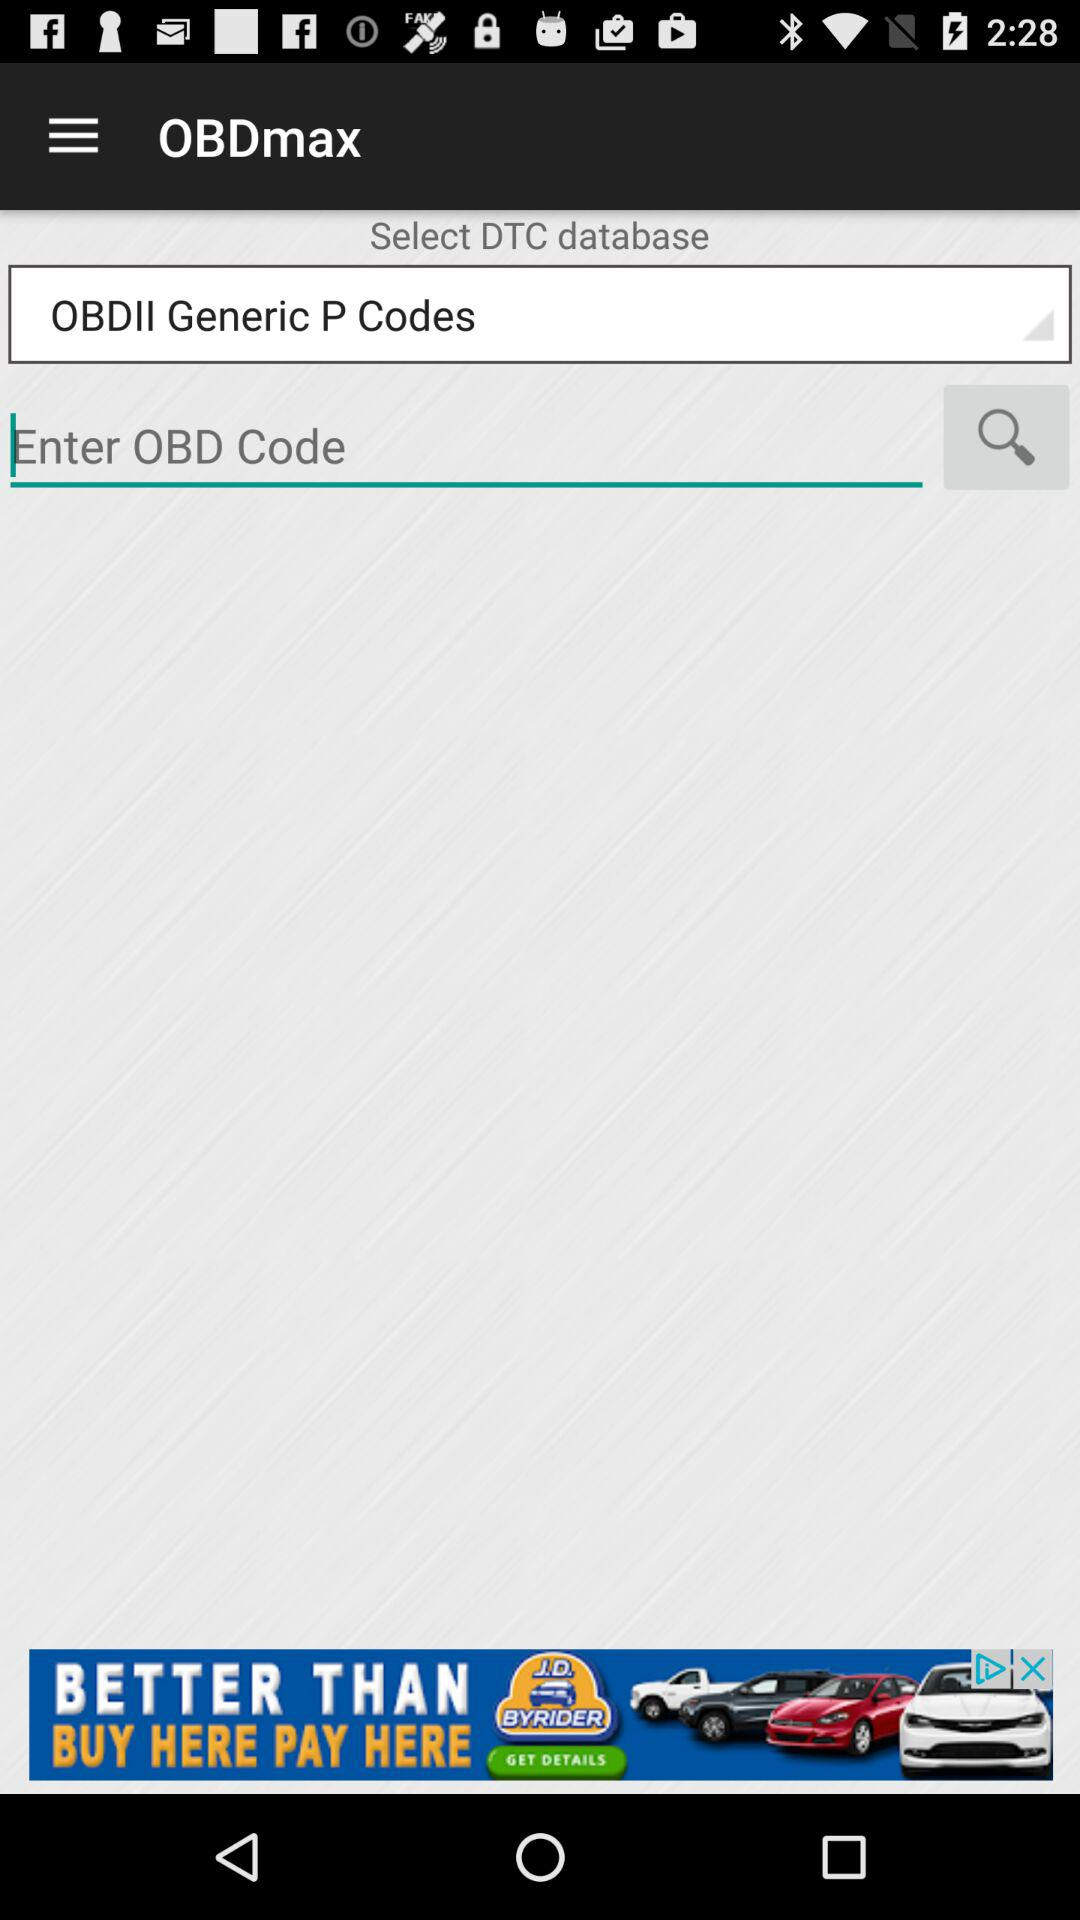What's the selected DTC database? The selected DTC database is "OBDII Generic P Codes". 